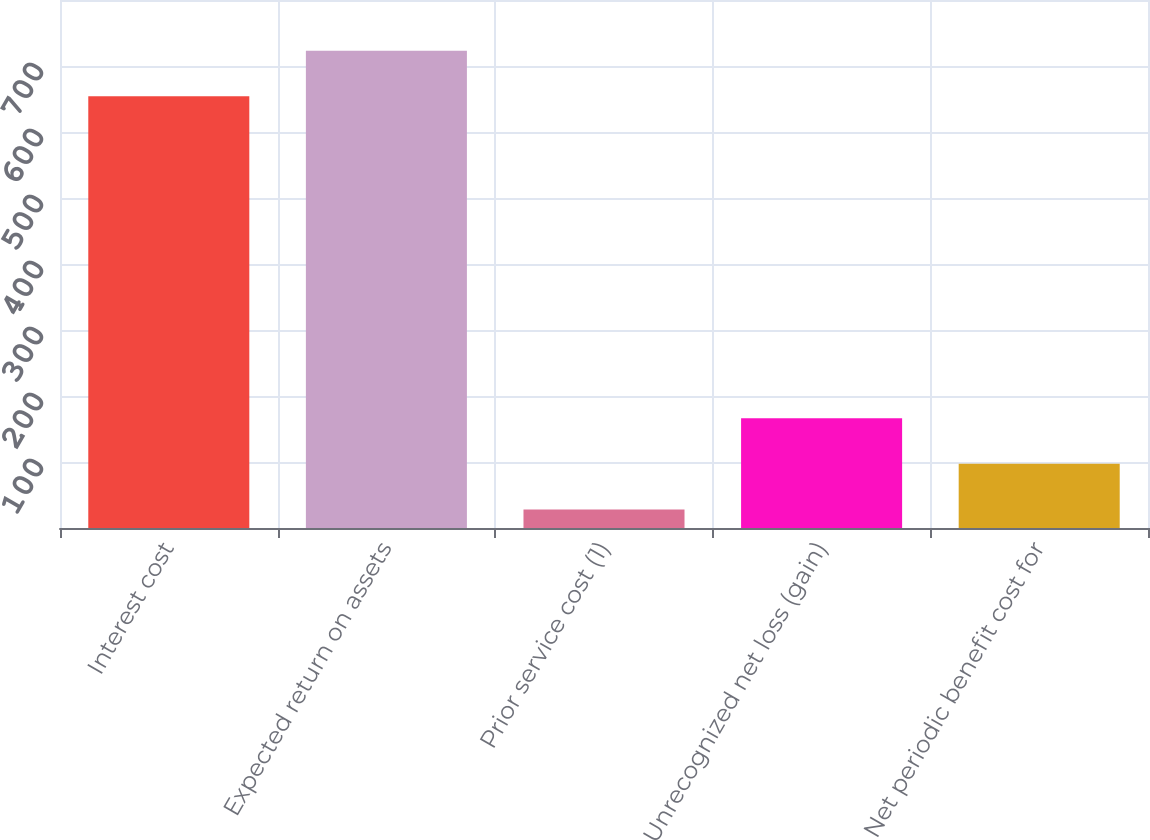Convert chart. <chart><loc_0><loc_0><loc_500><loc_500><bar_chart><fcel>Interest cost<fcel>Expected return on assets<fcel>Prior service cost (1)<fcel>Unrecognized net loss (gain)<fcel>Net periodic benefit cost for<nl><fcel>654<fcel>723.2<fcel>28<fcel>166.4<fcel>97.2<nl></chart> 